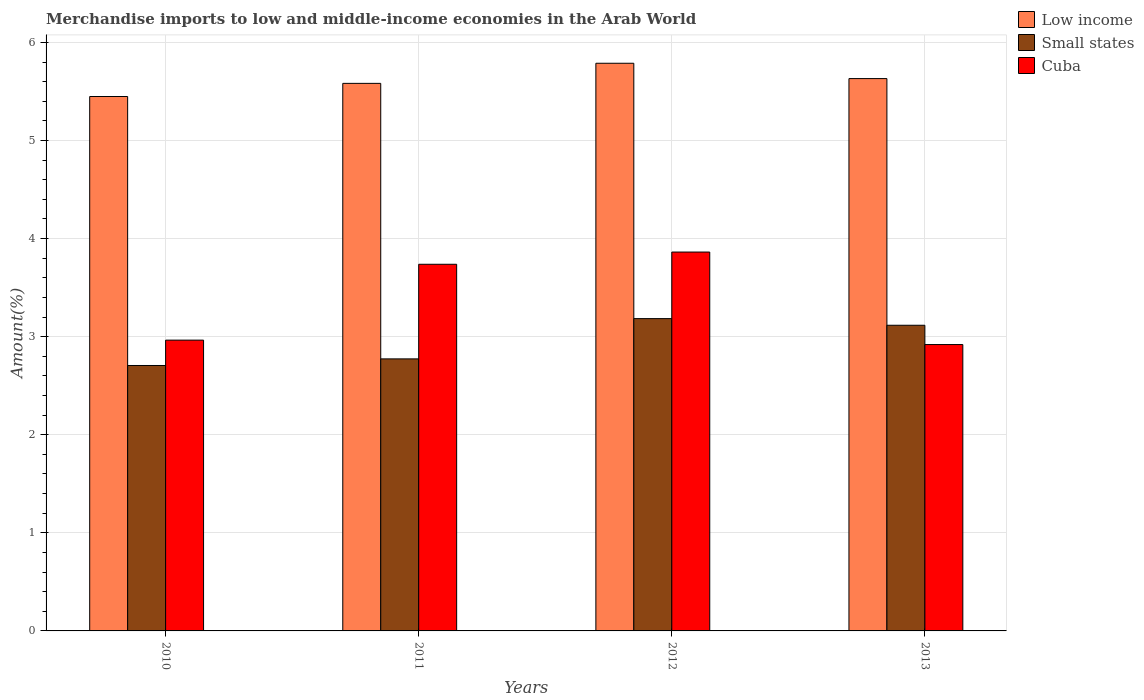How many different coloured bars are there?
Provide a succinct answer. 3. Are the number of bars per tick equal to the number of legend labels?
Ensure brevity in your answer.  Yes. Are the number of bars on each tick of the X-axis equal?
Offer a terse response. Yes. How many bars are there on the 3rd tick from the left?
Your response must be concise. 3. How many bars are there on the 1st tick from the right?
Provide a succinct answer. 3. What is the percentage of amount earned from merchandise imports in Low income in 2012?
Offer a terse response. 5.79. Across all years, what is the maximum percentage of amount earned from merchandise imports in Cuba?
Your answer should be very brief. 3.86. Across all years, what is the minimum percentage of amount earned from merchandise imports in Cuba?
Offer a very short reply. 2.92. In which year was the percentage of amount earned from merchandise imports in Small states maximum?
Your answer should be compact. 2012. What is the total percentage of amount earned from merchandise imports in Small states in the graph?
Keep it short and to the point. 11.78. What is the difference between the percentage of amount earned from merchandise imports in Low income in 2011 and that in 2012?
Give a very brief answer. -0.21. What is the difference between the percentage of amount earned from merchandise imports in Cuba in 2012 and the percentage of amount earned from merchandise imports in Low income in 2013?
Provide a short and direct response. -1.77. What is the average percentage of amount earned from merchandise imports in Small states per year?
Make the answer very short. 2.95. In the year 2010, what is the difference between the percentage of amount earned from merchandise imports in Low income and percentage of amount earned from merchandise imports in Small states?
Give a very brief answer. 2.74. In how many years, is the percentage of amount earned from merchandise imports in Low income greater than 3.4 %?
Your answer should be very brief. 4. What is the ratio of the percentage of amount earned from merchandise imports in Low income in 2011 to that in 2012?
Give a very brief answer. 0.96. Is the difference between the percentage of amount earned from merchandise imports in Low income in 2012 and 2013 greater than the difference between the percentage of amount earned from merchandise imports in Small states in 2012 and 2013?
Your answer should be very brief. Yes. What is the difference between the highest and the second highest percentage of amount earned from merchandise imports in Low income?
Ensure brevity in your answer.  0.16. What is the difference between the highest and the lowest percentage of amount earned from merchandise imports in Small states?
Make the answer very short. 0.48. In how many years, is the percentage of amount earned from merchandise imports in Small states greater than the average percentage of amount earned from merchandise imports in Small states taken over all years?
Offer a very short reply. 2. What does the 2nd bar from the left in 2010 represents?
Offer a terse response. Small states. What does the 3rd bar from the right in 2013 represents?
Your answer should be very brief. Low income. How many bars are there?
Offer a terse response. 12. How many years are there in the graph?
Provide a short and direct response. 4. Where does the legend appear in the graph?
Give a very brief answer. Top right. What is the title of the graph?
Offer a terse response. Merchandise imports to low and middle-income economies in the Arab World. Does "Austria" appear as one of the legend labels in the graph?
Keep it short and to the point. No. What is the label or title of the Y-axis?
Give a very brief answer. Amount(%). What is the Amount(%) in Low income in 2010?
Offer a very short reply. 5.45. What is the Amount(%) of Small states in 2010?
Your answer should be compact. 2.71. What is the Amount(%) of Cuba in 2010?
Your response must be concise. 2.96. What is the Amount(%) of Low income in 2011?
Keep it short and to the point. 5.58. What is the Amount(%) of Small states in 2011?
Your response must be concise. 2.77. What is the Amount(%) of Cuba in 2011?
Make the answer very short. 3.74. What is the Amount(%) in Low income in 2012?
Offer a terse response. 5.79. What is the Amount(%) in Small states in 2012?
Offer a very short reply. 3.18. What is the Amount(%) in Cuba in 2012?
Offer a very short reply. 3.86. What is the Amount(%) in Low income in 2013?
Your response must be concise. 5.63. What is the Amount(%) of Small states in 2013?
Offer a very short reply. 3.12. What is the Amount(%) of Cuba in 2013?
Your response must be concise. 2.92. Across all years, what is the maximum Amount(%) in Low income?
Give a very brief answer. 5.79. Across all years, what is the maximum Amount(%) in Small states?
Your response must be concise. 3.18. Across all years, what is the maximum Amount(%) in Cuba?
Ensure brevity in your answer.  3.86. Across all years, what is the minimum Amount(%) of Low income?
Provide a succinct answer. 5.45. Across all years, what is the minimum Amount(%) of Small states?
Offer a terse response. 2.71. Across all years, what is the minimum Amount(%) of Cuba?
Give a very brief answer. 2.92. What is the total Amount(%) in Low income in the graph?
Your response must be concise. 22.45. What is the total Amount(%) in Small states in the graph?
Your answer should be very brief. 11.78. What is the total Amount(%) of Cuba in the graph?
Provide a short and direct response. 13.49. What is the difference between the Amount(%) in Low income in 2010 and that in 2011?
Keep it short and to the point. -0.13. What is the difference between the Amount(%) in Small states in 2010 and that in 2011?
Provide a short and direct response. -0.07. What is the difference between the Amount(%) of Cuba in 2010 and that in 2011?
Provide a short and direct response. -0.77. What is the difference between the Amount(%) in Low income in 2010 and that in 2012?
Your answer should be very brief. -0.34. What is the difference between the Amount(%) of Small states in 2010 and that in 2012?
Provide a succinct answer. -0.48. What is the difference between the Amount(%) of Cuba in 2010 and that in 2012?
Offer a very short reply. -0.9. What is the difference between the Amount(%) in Low income in 2010 and that in 2013?
Give a very brief answer. -0.18. What is the difference between the Amount(%) of Small states in 2010 and that in 2013?
Keep it short and to the point. -0.41. What is the difference between the Amount(%) in Cuba in 2010 and that in 2013?
Keep it short and to the point. 0.05. What is the difference between the Amount(%) in Low income in 2011 and that in 2012?
Offer a terse response. -0.2. What is the difference between the Amount(%) in Small states in 2011 and that in 2012?
Your answer should be compact. -0.41. What is the difference between the Amount(%) of Cuba in 2011 and that in 2012?
Keep it short and to the point. -0.12. What is the difference between the Amount(%) in Low income in 2011 and that in 2013?
Make the answer very short. -0.05. What is the difference between the Amount(%) in Small states in 2011 and that in 2013?
Provide a short and direct response. -0.34. What is the difference between the Amount(%) of Cuba in 2011 and that in 2013?
Your answer should be compact. 0.82. What is the difference between the Amount(%) of Low income in 2012 and that in 2013?
Make the answer very short. 0.16. What is the difference between the Amount(%) of Small states in 2012 and that in 2013?
Your answer should be very brief. 0.07. What is the difference between the Amount(%) in Cuba in 2012 and that in 2013?
Your answer should be compact. 0.94. What is the difference between the Amount(%) of Low income in 2010 and the Amount(%) of Small states in 2011?
Make the answer very short. 2.68. What is the difference between the Amount(%) of Low income in 2010 and the Amount(%) of Cuba in 2011?
Keep it short and to the point. 1.71. What is the difference between the Amount(%) in Small states in 2010 and the Amount(%) in Cuba in 2011?
Offer a very short reply. -1.03. What is the difference between the Amount(%) in Low income in 2010 and the Amount(%) in Small states in 2012?
Your answer should be compact. 2.26. What is the difference between the Amount(%) in Low income in 2010 and the Amount(%) in Cuba in 2012?
Your response must be concise. 1.59. What is the difference between the Amount(%) in Small states in 2010 and the Amount(%) in Cuba in 2012?
Keep it short and to the point. -1.16. What is the difference between the Amount(%) of Low income in 2010 and the Amount(%) of Small states in 2013?
Your response must be concise. 2.33. What is the difference between the Amount(%) of Low income in 2010 and the Amount(%) of Cuba in 2013?
Keep it short and to the point. 2.53. What is the difference between the Amount(%) of Small states in 2010 and the Amount(%) of Cuba in 2013?
Ensure brevity in your answer.  -0.21. What is the difference between the Amount(%) of Low income in 2011 and the Amount(%) of Small states in 2012?
Your answer should be compact. 2.4. What is the difference between the Amount(%) in Low income in 2011 and the Amount(%) in Cuba in 2012?
Give a very brief answer. 1.72. What is the difference between the Amount(%) in Small states in 2011 and the Amount(%) in Cuba in 2012?
Provide a succinct answer. -1.09. What is the difference between the Amount(%) in Low income in 2011 and the Amount(%) in Small states in 2013?
Offer a very short reply. 2.47. What is the difference between the Amount(%) in Low income in 2011 and the Amount(%) in Cuba in 2013?
Give a very brief answer. 2.66. What is the difference between the Amount(%) in Small states in 2011 and the Amount(%) in Cuba in 2013?
Provide a short and direct response. -0.15. What is the difference between the Amount(%) in Low income in 2012 and the Amount(%) in Small states in 2013?
Your answer should be very brief. 2.67. What is the difference between the Amount(%) of Low income in 2012 and the Amount(%) of Cuba in 2013?
Offer a terse response. 2.87. What is the difference between the Amount(%) of Small states in 2012 and the Amount(%) of Cuba in 2013?
Your answer should be very brief. 0.26. What is the average Amount(%) in Low income per year?
Give a very brief answer. 5.61. What is the average Amount(%) in Small states per year?
Offer a very short reply. 2.95. What is the average Amount(%) in Cuba per year?
Provide a short and direct response. 3.37. In the year 2010, what is the difference between the Amount(%) of Low income and Amount(%) of Small states?
Your answer should be very brief. 2.74. In the year 2010, what is the difference between the Amount(%) in Low income and Amount(%) in Cuba?
Keep it short and to the point. 2.48. In the year 2010, what is the difference between the Amount(%) in Small states and Amount(%) in Cuba?
Ensure brevity in your answer.  -0.26. In the year 2011, what is the difference between the Amount(%) in Low income and Amount(%) in Small states?
Give a very brief answer. 2.81. In the year 2011, what is the difference between the Amount(%) in Low income and Amount(%) in Cuba?
Give a very brief answer. 1.84. In the year 2011, what is the difference between the Amount(%) of Small states and Amount(%) of Cuba?
Your response must be concise. -0.96. In the year 2012, what is the difference between the Amount(%) of Low income and Amount(%) of Small states?
Offer a terse response. 2.6. In the year 2012, what is the difference between the Amount(%) in Low income and Amount(%) in Cuba?
Provide a succinct answer. 1.92. In the year 2012, what is the difference between the Amount(%) of Small states and Amount(%) of Cuba?
Your answer should be very brief. -0.68. In the year 2013, what is the difference between the Amount(%) of Low income and Amount(%) of Small states?
Provide a short and direct response. 2.52. In the year 2013, what is the difference between the Amount(%) of Low income and Amount(%) of Cuba?
Provide a succinct answer. 2.71. In the year 2013, what is the difference between the Amount(%) of Small states and Amount(%) of Cuba?
Provide a succinct answer. 0.2. What is the ratio of the Amount(%) in Small states in 2010 to that in 2011?
Give a very brief answer. 0.98. What is the ratio of the Amount(%) of Cuba in 2010 to that in 2011?
Provide a short and direct response. 0.79. What is the ratio of the Amount(%) of Low income in 2010 to that in 2012?
Your response must be concise. 0.94. What is the ratio of the Amount(%) of Small states in 2010 to that in 2012?
Offer a terse response. 0.85. What is the ratio of the Amount(%) of Cuba in 2010 to that in 2012?
Your answer should be compact. 0.77. What is the ratio of the Amount(%) of Low income in 2010 to that in 2013?
Your answer should be very brief. 0.97. What is the ratio of the Amount(%) of Small states in 2010 to that in 2013?
Offer a very short reply. 0.87. What is the ratio of the Amount(%) of Cuba in 2010 to that in 2013?
Your response must be concise. 1.02. What is the ratio of the Amount(%) in Low income in 2011 to that in 2012?
Offer a very short reply. 0.96. What is the ratio of the Amount(%) of Small states in 2011 to that in 2012?
Make the answer very short. 0.87. What is the ratio of the Amount(%) of Low income in 2011 to that in 2013?
Provide a short and direct response. 0.99. What is the ratio of the Amount(%) of Small states in 2011 to that in 2013?
Offer a very short reply. 0.89. What is the ratio of the Amount(%) in Cuba in 2011 to that in 2013?
Your answer should be very brief. 1.28. What is the ratio of the Amount(%) in Low income in 2012 to that in 2013?
Your response must be concise. 1.03. What is the ratio of the Amount(%) in Small states in 2012 to that in 2013?
Provide a succinct answer. 1.02. What is the ratio of the Amount(%) of Cuba in 2012 to that in 2013?
Your answer should be compact. 1.32. What is the difference between the highest and the second highest Amount(%) of Low income?
Your answer should be very brief. 0.16. What is the difference between the highest and the second highest Amount(%) of Small states?
Ensure brevity in your answer.  0.07. What is the difference between the highest and the second highest Amount(%) of Cuba?
Make the answer very short. 0.12. What is the difference between the highest and the lowest Amount(%) in Low income?
Offer a very short reply. 0.34. What is the difference between the highest and the lowest Amount(%) of Small states?
Your response must be concise. 0.48. What is the difference between the highest and the lowest Amount(%) in Cuba?
Provide a succinct answer. 0.94. 